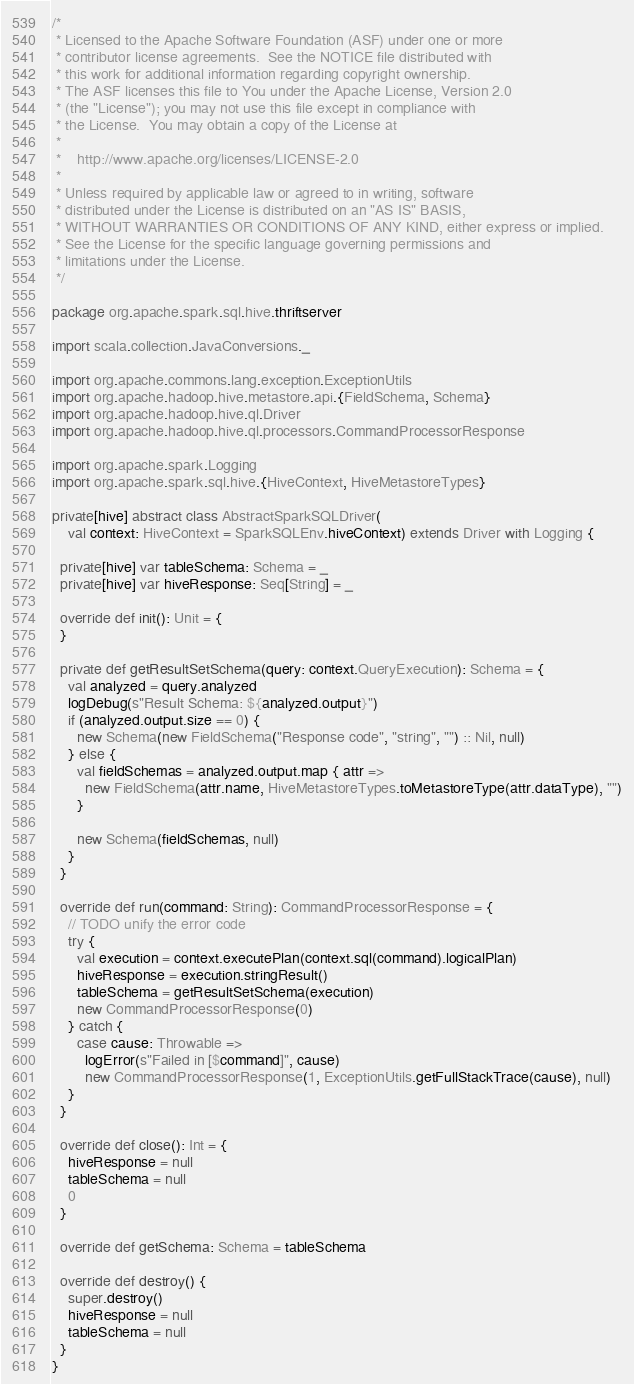<code> <loc_0><loc_0><loc_500><loc_500><_Scala_>/*
 * Licensed to the Apache Software Foundation (ASF) under one or more
 * contributor license agreements.  See the NOTICE file distributed with
 * this work for additional information regarding copyright ownership.
 * The ASF licenses this file to You under the Apache License, Version 2.0
 * (the "License"); you may not use this file except in compliance with
 * the License.  You may obtain a copy of the License at
 *
 *    http://www.apache.org/licenses/LICENSE-2.0
 *
 * Unless required by applicable law or agreed to in writing, software
 * distributed under the License is distributed on an "AS IS" BASIS,
 * WITHOUT WARRANTIES OR CONDITIONS OF ANY KIND, either express or implied.
 * See the License for the specific language governing permissions and
 * limitations under the License.
 */

package org.apache.spark.sql.hive.thriftserver

import scala.collection.JavaConversions._

import org.apache.commons.lang.exception.ExceptionUtils
import org.apache.hadoop.hive.metastore.api.{FieldSchema, Schema}
import org.apache.hadoop.hive.ql.Driver
import org.apache.hadoop.hive.ql.processors.CommandProcessorResponse

import org.apache.spark.Logging
import org.apache.spark.sql.hive.{HiveContext, HiveMetastoreTypes}

private[hive] abstract class AbstractSparkSQLDriver(
    val context: HiveContext = SparkSQLEnv.hiveContext) extends Driver with Logging {

  private[hive] var tableSchema: Schema = _
  private[hive] var hiveResponse: Seq[String] = _

  override def init(): Unit = {
  }

  private def getResultSetSchema(query: context.QueryExecution): Schema = {
    val analyzed = query.analyzed
    logDebug(s"Result Schema: ${analyzed.output}")
    if (analyzed.output.size == 0) {
      new Schema(new FieldSchema("Response code", "string", "") :: Nil, null)
    } else {
      val fieldSchemas = analyzed.output.map { attr =>
        new FieldSchema(attr.name, HiveMetastoreTypes.toMetastoreType(attr.dataType), "")
      }

      new Schema(fieldSchemas, null)
    }
  }

  override def run(command: String): CommandProcessorResponse = {
    // TODO unify the error code
    try {
      val execution = context.executePlan(context.sql(command).logicalPlan)
      hiveResponse = execution.stringResult()
      tableSchema = getResultSetSchema(execution)
      new CommandProcessorResponse(0)
    } catch {
      case cause: Throwable =>
        logError(s"Failed in [$command]", cause)
        new CommandProcessorResponse(1, ExceptionUtils.getFullStackTrace(cause), null)
    }
  }

  override def close(): Int = {
    hiveResponse = null
    tableSchema = null
    0
  }

  override def getSchema: Schema = tableSchema

  override def destroy() {
    super.destroy()
    hiveResponse = null
    tableSchema = null
  }
}
</code> 